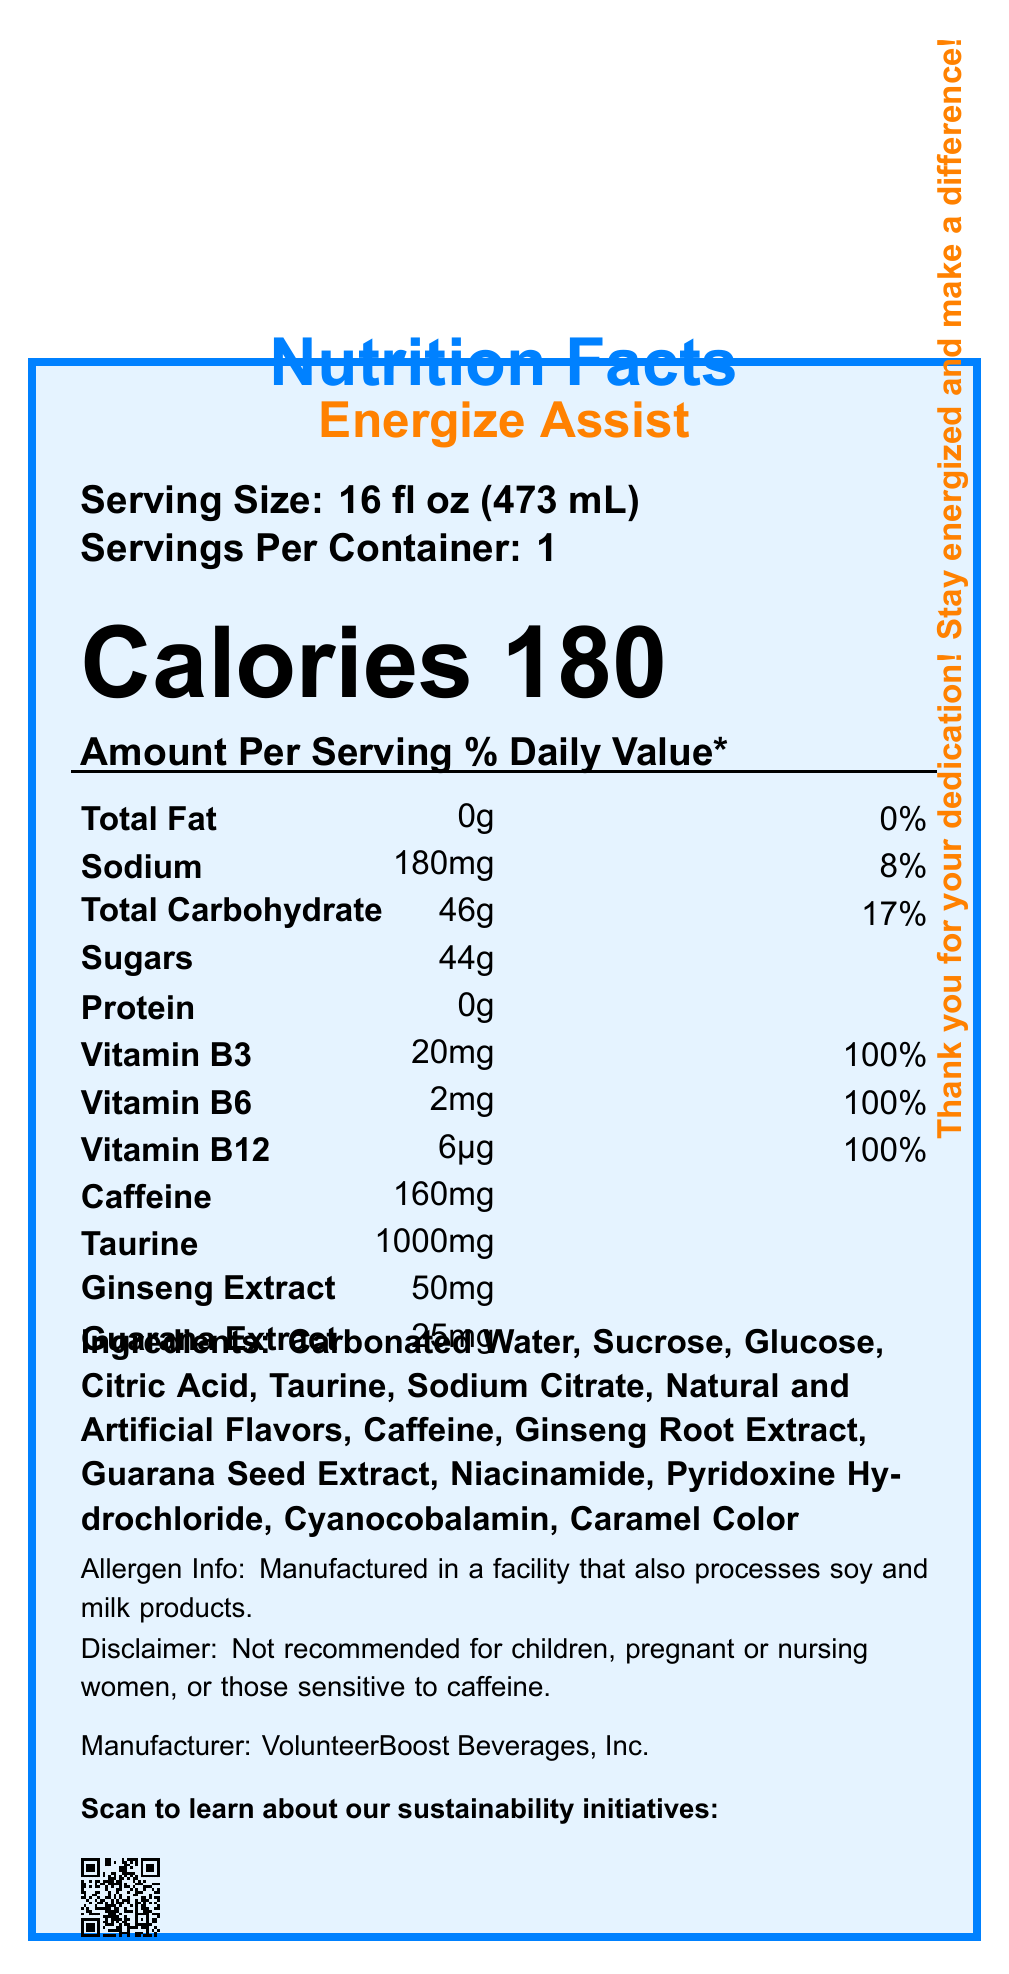How many servings are there per container of "Energize Assist"? The document states "Servings Per Container: 1".
Answer: 1 What is the serving size for "Energize Assist"? The document specifies the serving size as "16 fl oz (473 mL)".
Answer: 16 fl oz (473 mL) How many calories does one serving of "Energize Assist" contain? The document states "Calories 180".
Answer: 180 What is the amount of caffeine in one serving of "Energize Assist"? According to the document, the amount of caffeine per serving is "160mg".
Answer: 160mg What is the percentage of Daily Value for Sodium? The document lists the Daily Value of Sodium as "8%".
Answer: 8% Does "Energize Assist" contain any protein? The document indicates "Protein: 0g", meaning there is no protein.
Answer: No Is the energy drink suitable for children? The disclaimer in the document says, "Not recommended for children..."
Answer: No How much Vitamin B12 does the drink contain? A. 6μg B. 20mg C. 2mg The document specifies the amount of Vitamin B12 as 6μg.
Answer: A Which of the following ingredients is NOT present in "Energize Assist"? I. Carbonated Water II. Ginseng Root Extract III. Soy Milk The ingredient list includes Carbonated Water and Ginseng Root Extract, but not Soy Milk.
Answer: III What is the main source of carbohydrates in "Energize Assist"? A. Sucrose B. Protein C. Caffeine D. Taurine Sucrose is listed as an ingredient which is a primary source of carbohydrates.
Answer: A Is there any information about the drink's sustainability initiatives on the document? The document includes a QR code and a link to learn about sustainability initiatives.
Answer: Yes Summarize the key information provided in the Nutrition Facts Label for "Energize Assist". The summary explains the main details of the energy drink including its nutritional content, ingredients, allergen advice, and digital engagement opportunities.
Answer: "Energize Assist" is an energy drink with a serving size of 16 fl oz (473 mL) and one serving per container. It provides 180 calories, 0g total fat, 180mg sodium, 46g total carbohydrate (including 44g sugars), and no protein. Key vitamins and minerals include Vitamin B3, B6, and B12, each at 100% of the daily value. It contains 160mg of caffeine, along with taurine, ginseng extract, and guarana extract. Ingredients are listed, and allergen and consumer advisories are provided. The manufacturer is VolunteerBoost Beverages, Inc., and links to further digital engagement are included. What is the manufacturer of "Energize Assist"? The document states that the manufacturer is VolunteerBoost Beverages, Inc.
Answer: VolunteerBoost Beverages, Inc. What is the daily value percentage of Vitamin B6 in the drink? The document states that Vitamin B6 is present at 100% of the daily value.
Answer: 100% Can you determine the exact flavor of the "Energize Assist" energy drink from the document? The document lists "Natural and Artificial Flavors" but does not specify the exact flavor.
Answer: Cannot be determined 